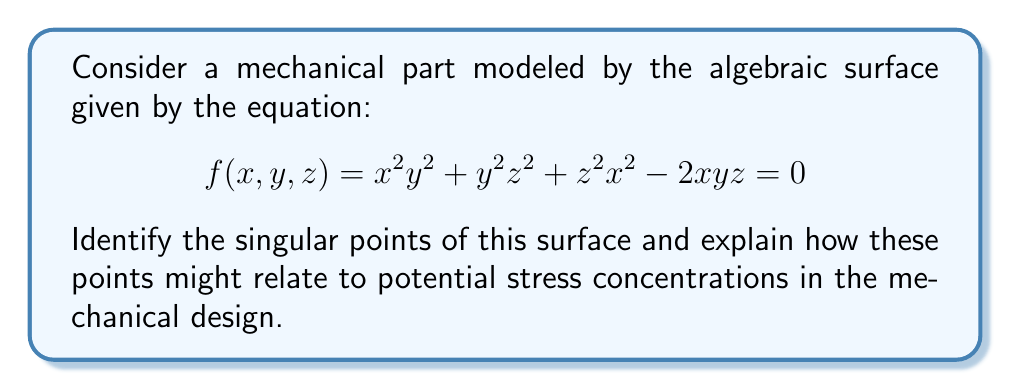Can you solve this math problem? To find the singular points of the surface, we need to follow these steps:

1) Calculate the partial derivatives of $f(x,y,z)$ with respect to $x$, $y$, and $z$:

   $\frac{\partial f}{\partial x} = 2xy^2 + 2zx^2 - 2yz$
   $\frac{\partial f}{\partial y} = 2x^2y + 2yz^2 - 2xz$
   $\frac{\partial f}{\partial z} = 2y^2z + 2zx^2 - 2xy$

2) Set each partial derivative equal to zero:

   $2xy^2 + 2zx^2 - 2yz = 0$
   $2x^2y + 2yz^2 - 2xz = 0$
   $2y^2z + 2zx^2 - 2xy = 0$

3) Solve this system of equations along with the original equation:

   $x^2y^2 + y^2z^2 + z^2x^2 - 2xyz = 0$

4) By inspection, we can see that $(0,0,0)$ satisfies all four equations. To find other solutions, we can factor out common terms:

   $2x(y^2 + x^2 - yz) = 0$
   $2y(x^2 + z^2 - xz) = 0$
   $2z(y^2 + x^2 - xy) = 0$

5) This system is satisfied when $x = y = z = 0$, or when:

   $y^2 + x^2 = yz$
   $x^2 + z^2 = xz$
   $y^2 + x^2 = xy$

6) Solving this system, we find additional singular points at:
   $(1,1,1)$, $(1,\omega,\omega^2)$, $(1,\omega^2,\omega)$, where $\omega = e^{2\pi i/3}$ is a cube root of unity.

In terms of mechanical design, singular points often correspond to sharp edges, corners, or points where the surface geometry changes abruptly. These locations are prone to stress concentrations, which could lead to material failure under load. The origin $(0,0,0)$ represents a point where three surfaces intersect, potentially forming a sharp corner. The other singular points, while complex, might represent locations where the surface has unusual geometry that could concentrate stress in physical implementations.

For a machinist, these points would be areas of concern when manufacturing the part, requiring careful attention to ensure smooth transitions and potentially adding fillets or chamfers to reduce stress concentrations.
Answer: Singular points: $(0,0,0)$, $(1,1,1)$, $(1,\omega,\omega^2)$, $(1,\omega^2,\omega)$, where $\omega = e^{2\pi i/3}$. These points indicate potential stress concentrations in the mechanical design. 